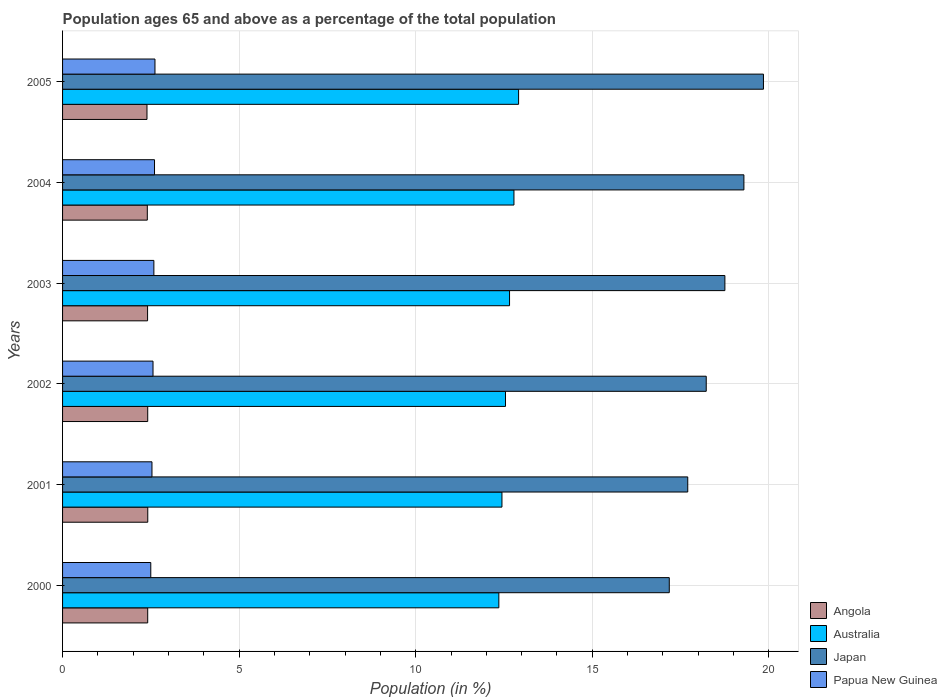Are the number of bars per tick equal to the number of legend labels?
Your answer should be very brief. Yes. How many bars are there on the 5th tick from the bottom?
Offer a terse response. 4. What is the label of the 2nd group of bars from the top?
Your answer should be very brief. 2004. What is the percentage of the population ages 65 and above in Japan in 2002?
Keep it short and to the point. 18.23. Across all years, what is the maximum percentage of the population ages 65 and above in Angola?
Offer a terse response. 2.41. Across all years, what is the minimum percentage of the population ages 65 and above in Japan?
Ensure brevity in your answer.  17.18. In which year was the percentage of the population ages 65 and above in Japan maximum?
Your answer should be very brief. 2005. In which year was the percentage of the population ages 65 and above in Angola minimum?
Provide a succinct answer. 2005. What is the total percentage of the population ages 65 and above in Angola in the graph?
Your response must be concise. 14.43. What is the difference between the percentage of the population ages 65 and above in Australia in 2002 and that in 2005?
Your answer should be compact. -0.37. What is the difference between the percentage of the population ages 65 and above in Australia in 2000 and the percentage of the population ages 65 and above in Angola in 2003?
Ensure brevity in your answer.  9.95. What is the average percentage of the population ages 65 and above in Australia per year?
Your answer should be very brief. 12.62. In the year 2000, what is the difference between the percentage of the population ages 65 and above in Papua New Guinea and percentage of the population ages 65 and above in Angola?
Offer a terse response. 0.09. What is the ratio of the percentage of the population ages 65 and above in Papua New Guinea in 2001 to that in 2003?
Your answer should be compact. 0.98. Is the percentage of the population ages 65 and above in Angola in 2000 less than that in 2003?
Provide a short and direct response. No. Is the difference between the percentage of the population ages 65 and above in Papua New Guinea in 2000 and 2003 greater than the difference between the percentage of the population ages 65 and above in Angola in 2000 and 2003?
Your response must be concise. No. What is the difference between the highest and the second highest percentage of the population ages 65 and above in Australia?
Make the answer very short. 0.13. What is the difference between the highest and the lowest percentage of the population ages 65 and above in Papua New Guinea?
Keep it short and to the point. 0.12. Is it the case that in every year, the sum of the percentage of the population ages 65 and above in Papua New Guinea and percentage of the population ages 65 and above in Japan is greater than the sum of percentage of the population ages 65 and above in Angola and percentage of the population ages 65 and above in Australia?
Your response must be concise. Yes. What does the 3rd bar from the top in 2000 represents?
Make the answer very short. Australia. What does the 1st bar from the bottom in 2000 represents?
Offer a very short reply. Angola. Are all the bars in the graph horizontal?
Provide a short and direct response. Yes. How many years are there in the graph?
Your response must be concise. 6. What is the difference between two consecutive major ticks on the X-axis?
Keep it short and to the point. 5. Are the values on the major ticks of X-axis written in scientific E-notation?
Keep it short and to the point. No. Does the graph contain any zero values?
Provide a short and direct response. No. Does the graph contain grids?
Offer a very short reply. Yes. How are the legend labels stacked?
Make the answer very short. Vertical. What is the title of the graph?
Ensure brevity in your answer.  Population ages 65 and above as a percentage of the total population. Does "Zambia" appear as one of the legend labels in the graph?
Keep it short and to the point. No. What is the label or title of the X-axis?
Your answer should be compact. Population (in %). What is the Population (in %) in Angola in 2000?
Your answer should be compact. 2.41. What is the Population (in %) of Australia in 2000?
Your answer should be very brief. 12.35. What is the Population (in %) in Japan in 2000?
Give a very brief answer. 17.18. What is the Population (in %) in Papua New Guinea in 2000?
Your answer should be very brief. 2.5. What is the Population (in %) of Angola in 2001?
Make the answer very short. 2.41. What is the Population (in %) in Australia in 2001?
Ensure brevity in your answer.  12.44. What is the Population (in %) of Japan in 2001?
Offer a very short reply. 17.7. What is the Population (in %) of Papua New Guinea in 2001?
Your answer should be very brief. 2.53. What is the Population (in %) in Angola in 2002?
Make the answer very short. 2.41. What is the Population (in %) of Australia in 2002?
Provide a short and direct response. 12.54. What is the Population (in %) of Japan in 2002?
Your answer should be very brief. 18.23. What is the Population (in %) of Papua New Guinea in 2002?
Offer a terse response. 2.56. What is the Population (in %) of Angola in 2003?
Ensure brevity in your answer.  2.41. What is the Population (in %) of Australia in 2003?
Make the answer very short. 12.66. What is the Population (in %) in Japan in 2003?
Make the answer very short. 18.75. What is the Population (in %) of Papua New Guinea in 2003?
Ensure brevity in your answer.  2.59. What is the Population (in %) in Angola in 2004?
Give a very brief answer. 2.4. What is the Population (in %) in Australia in 2004?
Your answer should be very brief. 12.78. What is the Population (in %) in Japan in 2004?
Your response must be concise. 19.29. What is the Population (in %) of Papua New Guinea in 2004?
Offer a terse response. 2.6. What is the Population (in %) of Angola in 2005?
Provide a short and direct response. 2.39. What is the Population (in %) in Australia in 2005?
Give a very brief answer. 12.91. What is the Population (in %) of Japan in 2005?
Offer a very short reply. 19.85. What is the Population (in %) in Papua New Guinea in 2005?
Provide a short and direct response. 2.62. Across all years, what is the maximum Population (in %) of Angola?
Your answer should be very brief. 2.41. Across all years, what is the maximum Population (in %) in Australia?
Make the answer very short. 12.91. Across all years, what is the maximum Population (in %) in Japan?
Ensure brevity in your answer.  19.85. Across all years, what is the maximum Population (in %) in Papua New Guinea?
Your response must be concise. 2.62. Across all years, what is the minimum Population (in %) in Angola?
Provide a short and direct response. 2.39. Across all years, what is the minimum Population (in %) in Australia?
Give a very brief answer. 12.35. Across all years, what is the minimum Population (in %) of Japan?
Offer a terse response. 17.18. Across all years, what is the minimum Population (in %) in Papua New Guinea?
Provide a short and direct response. 2.5. What is the total Population (in %) in Angola in the graph?
Your answer should be compact. 14.43. What is the total Population (in %) in Australia in the graph?
Your answer should be very brief. 75.69. What is the total Population (in %) of Japan in the graph?
Provide a short and direct response. 111.01. What is the total Population (in %) in Papua New Guinea in the graph?
Ensure brevity in your answer.  15.4. What is the difference between the Population (in %) in Angola in 2000 and that in 2001?
Keep it short and to the point. -0. What is the difference between the Population (in %) in Australia in 2000 and that in 2001?
Your response must be concise. -0.09. What is the difference between the Population (in %) in Japan in 2000 and that in 2001?
Make the answer very short. -0.52. What is the difference between the Population (in %) of Papua New Guinea in 2000 and that in 2001?
Give a very brief answer. -0.03. What is the difference between the Population (in %) of Angola in 2000 and that in 2002?
Provide a succinct answer. -0. What is the difference between the Population (in %) of Australia in 2000 and that in 2002?
Your answer should be compact. -0.19. What is the difference between the Population (in %) of Japan in 2000 and that in 2002?
Make the answer very short. -1.05. What is the difference between the Population (in %) in Papua New Guinea in 2000 and that in 2002?
Provide a succinct answer. -0.06. What is the difference between the Population (in %) in Angola in 2000 and that in 2003?
Your answer should be compact. 0. What is the difference between the Population (in %) of Australia in 2000 and that in 2003?
Your answer should be very brief. -0.3. What is the difference between the Population (in %) in Japan in 2000 and that in 2003?
Offer a very short reply. -1.57. What is the difference between the Population (in %) of Papua New Guinea in 2000 and that in 2003?
Provide a short and direct response. -0.09. What is the difference between the Population (in %) of Angola in 2000 and that in 2004?
Provide a succinct answer. 0.01. What is the difference between the Population (in %) in Australia in 2000 and that in 2004?
Your answer should be compact. -0.43. What is the difference between the Population (in %) of Japan in 2000 and that in 2004?
Your answer should be compact. -2.11. What is the difference between the Population (in %) of Papua New Guinea in 2000 and that in 2004?
Provide a short and direct response. -0.11. What is the difference between the Population (in %) of Australia in 2000 and that in 2005?
Keep it short and to the point. -0.56. What is the difference between the Population (in %) of Japan in 2000 and that in 2005?
Ensure brevity in your answer.  -2.67. What is the difference between the Population (in %) in Papua New Guinea in 2000 and that in 2005?
Provide a succinct answer. -0.12. What is the difference between the Population (in %) of Angola in 2001 and that in 2002?
Offer a terse response. 0. What is the difference between the Population (in %) of Australia in 2001 and that in 2002?
Make the answer very short. -0.1. What is the difference between the Population (in %) in Japan in 2001 and that in 2002?
Offer a very short reply. -0.52. What is the difference between the Population (in %) in Papua New Guinea in 2001 and that in 2002?
Provide a short and direct response. -0.03. What is the difference between the Population (in %) of Angola in 2001 and that in 2003?
Keep it short and to the point. 0.01. What is the difference between the Population (in %) in Australia in 2001 and that in 2003?
Make the answer very short. -0.22. What is the difference between the Population (in %) in Japan in 2001 and that in 2003?
Ensure brevity in your answer.  -1.05. What is the difference between the Population (in %) in Papua New Guinea in 2001 and that in 2003?
Your response must be concise. -0.05. What is the difference between the Population (in %) in Angola in 2001 and that in 2004?
Your response must be concise. 0.01. What is the difference between the Population (in %) in Australia in 2001 and that in 2004?
Your answer should be very brief. -0.34. What is the difference between the Population (in %) in Japan in 2001 and that in 2004?
Offer a terse response. -1.59. What is the difference between the Population (in %) in Papua New Guinea in 2001 and that in 2004?
Offer a very short reply. -0.07. What is the difference between the Population (in %) of Angola in 2001 and that in 2005?
Make the answer very short. 0.02. What is the difference between the Population (in %) of Australia in 2001 and that in 2005?
Provide a succinct answer. -0.47. What is the difference between the Population (in %) in Japan in 2001 and that in 2005?
Give a very brief answer. -2.14. What is the difference between the Population (in %) of Papua New Guinea in 2001 and that in 2005?
Make the answer very short. -0.08. What is the difference between the Population (in %) of Angola in 2002 and that in 2003?
Provide a succinct answer. 0. What is the difference between the Population (in %) in Australia in 2002 and that in 2003?
Offer a very short reply. -0.11. What is the difference between the Population (in %) in Japan in 2002 and that in 2003?
Your response must be concise. -0.53. What is the difference between the Population (in %) of Papua New Guinea in 2002 and that in 2003?
Ensure brevity in your answer.  -0.02. What is the difference between the Population (in %) of Angola in 2002 and that in 2004?
Offer a very short reply. 0.01. What is the difference between the Population (in %) of Australia in 2002 and that in 2004?
Make the answer very short. -0.24. What is the difference between the Population (in %) in Japan in 2002 and that in 2004?
Your answer should be compact. -1.07. What is the difference between the Population (in %) in Papua New Guinea in 2002 and that in 2004?
Your response must be concise. -0.04. What is the difference between the Population (in %) of Angola in 2002 and that in 2005?
Offer a very short reply. 0.02. What is the difference between the Population (in %) of Australia in 2002 and that in 2005?
Provide a short and direct response. -0.37. What is the difference between the Population (in %) in Japan in 2002 and that in 2005?
Provide a succinct answer. -1.62. What is the difference between the Population (in %) of Papua New Guinea in 2002 and that in 2005?
Your answer should be compact. -0.06. What is the difference between the Population (in %) in Angola in 2003 and that in 2004?
Provide a succinct answer. 0.01. What is the difference between the Population (in %) of Australia in 2003 and that in 2004?
Your response must be concise. -0.12. What is the difference between the Population (in %) in Japan in 2003 and that in 2004?
Offer a terse response. -0.54. What is the difference between the Population (in %) of Papua New Guinea in 2003 and that in 2004?
Give a very brief answer. -0.02. What is the difference between the Population (in %) in Angola in 2003 and that in 2005?
Make the answer very short. 0.02. What is the difference between the Population (in %) in Australia in 2003 and that in 2005?
Your response must be concise. -0.26. What is the difference between the Population (in %) of Japan in 2003 and that in 2005?
Provide a succinct answer. -1.09. What is the difference between the Population (in %) of Papua New Guinea in 2003 and that in 2005?
Ensure brevity in your answer.  -0.03. What is the difference between the Population (in %) in Angola in 2004 and that in 2005?
Your answer should be compact. 0.01. What is the difference between the Population (in %) in Australia in 2004 and that in 2005?
Offer a very short reply. -0.13. What is the difference between the Population (in %) of Japan in 2004 and that in 2005?
Your answer should be very brief. -0.55. What is the difference between the Population (in %) in Papua New Guinea in 2004 and that in 2005?
Your response must be concise. -0.01. What is the difference between the Population (in %) of Angola in 2000 and the Population (in %) of Australia in 2001?
Your answer should be very brief. -10.03. What is the difference between the Population (in %) of Angola in 2000 and the Population (in %) of Japan in 2001?
Provide a succinct answer. -15.29. What is the difference between the Population (in %) in Angola in 2000 and the Population (in %) in Papua New Guinea in 2001?
Offer a terse response. -0.12. What is the difference between the Population (in %) of Australia in 2000 and the Population (in %) of Japan in 2001?
Give a very brief answer. -5.35. What is the difference between the Population (in %) of Australia in 2000 and the Population (in %) of Papua New Guinea in 2001?
Provide a succinct answer. 9.82. What is the difference between the Population (in %) in Japan in 2000 and the Population (in %) in Papua New Guinea in 2001?
Offer a terse response. 14.65. What is the difference between the Population (in %) of Angola in 2000 and the Population (in %) of Australia in 2002?
Keep it short and to the point. -10.13. What is the difference between the Population (in %) of Angola in 2000 and the Population (in %) of Japan in 2002?
Your answer should be compact. -15.82. What is the difference between the Population (in %) in Angola in 2000 and the Population (in %) in Papua New Guinea in 2002?
Ensure brevity in your answer.  -0.15. What is the difference between the Population (in %) of Australia in 2000 and the Population (in %) of Japan in 2002?
Offer a very short reply. -5.87. What is the difference between the Population (in %) in Australia in 2000 and the Population (in %) in Papua New Guinea in 2002?
Keep it short and to the point. 9.79. What is the difference between the Population (in %) in Japan in 2000 and the Population (in %) in Papua New Guinea in 2002?
Your answer should be very brief. 14.62. What is the difference between the Population (in %) in Angola in 2000 and the Population (in %) in Australia in 2003?
Ensure brevity in your answer.  -10.25. What is the difference between the Population (in %) of Angola in 2000 and the Population (in %) of Japan in 2003?
Offer a terse response. -16.34. What is the difference between the Population (in %) of Angola in 2000 and the Population (in %) of Papua New Guinea in 2003?
Provide a succinct answer. -0.17. What is the difference between the Population (in %) in Australia in 2000 and the Population (in %) in Japan in 2003?
Give a very brief answer. -6.4. What is the difference between the Population (in %) of Australia in 2000 and the Population (in %) of Papua New Guinea in 2003?
Your answer should be compact. 9.77. What is the difference between the Population (in %) in Japan in 2000 and the Population (in %) in Papua New Guinea in 2003?
Give a very brief answer. 14.6. What is the difference between the Population (in %) in Angola in 2000 and the Population (in %) in Australia in 2004?
Ensure brevity in your answer.  -10.37. What is the difference between the Population (in %) of Angola in 2000 and the Population (in %) of Japan in 2004?
Keep it short and to the point. -16.88. What is the difference between the Population (in %) of Angola in 2000 and the Population (in %) of Papua New Guinea in 2004?
Provide a short and direct response. -0.19. What is the difference between the Population (in %) in Australia in 2000 and the Population (in %) in Japan in 2004?
Make the answer very short. -6.94. What is the difference between the Population (in %) in Australia in 2000 and the Population (in %) in Papua New Guinea in 2004?
Your answer should be compact. 9.75. What is the difference between the Population (in %) in Japan in 2000 and the Population (in %) in Papua New Guinea in 2004?
Your answer should be compact. 14.58. What is the difference between the Population (in %) in Angola in 2000 and the Population (in %) in Australia in 2005?
Give a very brief answer. -10.5. What is the difference between the Population (in %) in Angola in 2000 and the Population (in %) in Japan in 2005?
Keep it short and to the point. -17.44. What is the difference between the Population (in %) in Angola in 2000 and the Population (in %) in Papua New Guinea in 2005?
Your answer should be compact. -0.21. What is the difference between the Population (in %) of Australia in 2000 and the Population (in %) of Japan in 2005?
Provide a short and direct response. -7.49. What is the difference between the Population (in %) of Australia in 2000 and the Population (in %) of Papua New Guinea in 2005?
Keep it short and to the point. 9.74. What is the difference between the Population (in %) in Japan in 2000 and the Population (in %) in Papua New Guinea in 2005?
Offer a terse response. 14.56. What is the difference between the Population (in %) of Angola in 2001 and the Population (in %) of Australia in 2002?
Your answer should be very brief. -10.13. What is the difference between the Population (in %) of Angola in 2001 and the Population (in %) of Japan in 2002?
Make the answer very short. -15.81. What is the difference between the Population (in %) in Angola in 2001 and the Population (in %) in Papua New Guinea in 2002?
Keep it short and to the point. -0.15. What is the difference between the Population (in %) of Australia in 2001 and the Population (in %) of Japan in 2002?
Offer a very short reply. -5.78. What is the difference between the Population (in %) in Australia in 2001 and the Population (in %) in Papua New Guinea in 2002?
Make the answer very short. 9.88. What is the difference between the Population (in %) of Japan in 2001 and the Population (in %) of Papua New Guinea in 2002?
Make the answer very short. 15.14. What is the difference between the Population (in %) of Angola in 2001 and the Population (in %) of Australia in 2003?
Give a very brief answer. -10.24. What is the difference between the Population (in %) of Angola in 2001 and the Population (in %) of Japan in 2003?
Ensure brevity in your answer.  -16.34. What is the difference between the Population (in %) of Angola in 2001 and the Population (in %) of Papua New Guinea in 2003?
Offer a very short reply. -0.17. What is the difference between the Population (in %) in Australia in 2001 and the Population (in %) in Japan in 2003?
Your response must be concise. -6.31. What is the difference between the Population (in %) in Australia in 2001 and the Population (in %) in Papua New Guinea in 2003?
Offer a very short reply. 9.86. What is the difference between the Population (in %) in Japan in 2001 and the Population (in %) in Papua New Guinea in 2003?
Ensure brevity in your answer.  15.12. What is the difference between the Population (in %) of Angola in 2001 and the Population (in %) of Australia in 2004?
Your response must be concise. -10.37. What is the difference between the Population (in %) of Angola in 2001 and the Population (in %) of Japan in 2004?
Keep it short and to the point. -16.88. What is the difference between the Population (in %) of Angola in 2001 and the Population (in %) of Papua New Guinea in 2004?
Make the answer very short. -0.19. What is the difference between the Population (in %) of Australia in 2001 and the Population (in %) of Japan in 2004?
Ensure brevity in your answer.  -6.85. What is the difference between the Population (in %) of Australia in 2001 and the Population (in %) of Papua New Guinea in 2004?
Offer a very short reply. 9.84. What is the difference between the Population (in %) of Japan in 2001 and the Population (in %) of Papua New Guinea in 2004?
Your response must be concise. 15.1. What is the difference between the Population (in %) in Angola in 2001 and the Population (in %) in Australia in 2005?
Your response must be concise. -10.5. What is the difference between the Population (in %) in Angola in 2001 and the Population (in %) in Japan in 2005?
Keep it short and to the point. -17.43. What is the difference between the Population (in %) in Angola in 2001 and the Population (in %) in Papua New Guinea in 2005?
Your answer should be compact. -0.2. What is the difference between the Population (in %) of Australia in 2001 and the Population (in %) of Japan in 2005?
Offer a very short reply. -7.4. What is the difference between the Population (in %) in Australia in 2001 and the Population (in %) in Papua New Guinea in 2005?
Offer a terse response. 9.83. What is the difference between the Population (in %) of Japan in 2001 and the Population (in %) of Papua New Guinea in 2005?
Ensure brevity in your answer.  15.09. What is the difference between the Population (in %) in Angola in 2002 and the Population (in %) in Australia in 2003?
Provide a short and direct response. -10.25. What is the difference between the Population (in %) of Angola in 2002 and the Population (in %) of Japan in 2003?
Your answer should be very brief. -16.34. What is the difference between the Population (in %) in Angola in 2002 and the Population (in %) in Papua New Guinea in 2003?
Provide a succinct answer. -0.17. What is the difference between the Population (in %) in Australia in 2002 and the Population (in %) in Japan in 2003?
Offer a very short reply. -6.21. What is the difference between the Population (in %) in Australia in 2002 and the Population (in %) in Papua New Guinea in 2003?
Your response must be concise. 9.96. What is the difference between the Population (in %) in Japan in 2002 and the Population (in %) in Papua New Guinea in 2003?
Offer a very short reply. 15.64. What is the difference between the Population (in %) of Angola in 2002 and the Population (in %) of Australia in 2004?
Offer a very short reply. -10.37. What is the difference between the Population (in %) of Angola in 2002 and the Population (in %) of Japan in 2004?
Offer a very short reply. -16.88. What is the difference between the Population (in %) in Angola in 2002 and the Population (in %) in Papua New Guinea in 2004?
Provide a succinct answer. -0.19. What is the difference between the Population (in %) in Australia in 2002 and the Population (in %) in Japan in 2004?
Ensure brevity in your answer.  -6.75. What is the difference between the Population (in %) in Australia in 2002 and the Population (in %) in Papua New Guinea in 2004?
Offer a very short reply. 9.94. What is the difference between the Population (in %) in Japan in 2002 and the Population (in %) in Papua New Guinea in 2004?
Give a very brief answer. 15.62. What is the difference between the Population (in %) in Angola in 2002 and the Population (in %) in Australia in 2005?
Offer a terse response. -10.5. What is the difference between the Population (in %) of Angola in 2002 and the Population (in %) of Japan in 2005?
Make the answer very short. -17.44. What is the difference between the Population (in %) of Angola in 2002 and the Population (in %) of Papua New Guinea in 2005?
Your answer should be very brief. -0.2. What is the difference between the Population (in %) of Australia in 2002 and the Population (in %) of Japan in 2005?
Provide a short and direct response. -7.3. What is the difference between the Population (in %) in Australia in 2002 and the Population (in %) in Papua New Guinea in 2005?
Provide a short and direct response. 9.93. What is the difference between the Population (in %) of Japan in 2002 and the Population (in %) of Papua New Guinea in 2005?
Provide a succinct answer. 15.61. What is the difference between the Population (in %) in Angola in 2003 and the Population (in %) in Australia in 2004?
Keep it short and to the point. -10.37. What is the difference between the Population (in %) of Angola in 2003 and the Population (in %) of Japan in 2004?
Provide a short and direct response. -16.89. What is the difference between the Population (in %) in Angola in 2003 and the Population (in %) in Papua New Guinea in 2004?
Provide a succinct answer. -0.2. What is the difference between the Population (in %) in Australia in 2003 and the Population (in %) in Japan in 2004?
Offer a very short reply. -6.64. What is the difference between the Population (in %) in Australia in 2003 and the Population (in %) in Papua New Guinea in 2004?
Your answer should be compact. 10.05. What is the difference between the Population (in %) in Japan in 2003 and the Population (in %) in Papua New Guinea in 2004?
Offer a very short reply. 16.15. What is the difference between the Population (in %) of Angola in 2003 and the Population (in %) of Australia in 2005?
Provide a short and direct response. -10.51. What is the difference between the Population (in %) in Angola in 2003 and the Population (in %) in Japan in 2005?
Offer a very short reply. -17.44. What is the difference between the Population (in %) in Angola in 2003 and the Population (in %) in Papua New Guinea in 2005?
Provide a short and direct response. -0.21. What is the difference between the Population (in %) of Australia in 2003 and the Population (in %) of Japan in 2005?
Provide a succinct answer. -7.19. What is the difference between the Population (in %) of Australia in 2003 and the Population (in %) of Papua New Guinea in 2005?
Ensure brevity in your answer.  10.04. What is the difference between the Population (in %) in Japan in 2003 and the Population (in %) in Papua New Guinea in 2005?
Your answer should be very brief. 16.14. What is the difference between the Population (in %) of Angola in 2004 and the Population (in %) of Australia in 2005?
Provide a succinct answer. -10.51. What is the difference between the Population (in %) in Angola in 2004 and the Population (in %) in Japan in 2005?
Give a very brief answer. -17.45. What is the difference between the Population (in %) in Angola in 2004 and the Population (in %) in Papua New Guinea in 2005?
Your response must be concise. -0.22. What is the difference between the Population (in %) in Australia in 2004 and the Population (in %) in Japan in 2005?
Make the answer very short. -7.06. What is the difference between the Population (in %) of Australia in 2004 and the Population (in %) of Papua New Guinea in 2005?
Give a very brief answer. 10.17. What is the difference between the Population (in %) in Japan in 2004 and the Population (in %) in Papua New Guinea in 2005?
Offer a very short reply. 16.68. What is the average Population (in %) of Angola per year?
Offer a very short reply. 2.41. What is the average Population (in %) in Australia per year?
Offer a very short reply. 12.62. What is the average Population (in %) of Japan per year?
Keep it short and to the point. 18.5. What is the average Population (in %) of Papua New Guinea per year?
Make the answer very short. 2.57. In the year 2000, what is the difference between the Population (in %) in Angola and Population (in %) in Australia?
Keep it short and to the point. -9.94. In the year 2000, what is the difference between the Population (in %) in Angola and Population (in %) in Japan?
Provide a succinct answer. -14.77. In the year 2000, what is the difference between the Population (in %) in Angola and Population (in %) in Papua New Guinea?
Provide a short and direct response. -0.09. In the year 2000, what is the difference between the Population (in %) of Australia and Population (in %) of Japan?
Give a very brief answer. -4.83. In the year 2000, what is the difference between the Population (in %) in Australia and Population (in %) in Papua New Guinea?
Make the answer very short. 9.86. In the year 2000, what is the difference between the Population (in %) of Japan and Population (in %) of Papua New Guinea?
Your response must be concise. 14.68. In the year 2001, what is the difference between the Population (in %) in Angola and Population (in %) in Australia?
Your answer should be compact. -10.03. In the year 2001, what is the difference between the Population (in %) of Angola and Population (in %) of Japan?
Keep it short and to the point. -15.29. In the year 2001, what is the difference between the Population (in %) in Angola and Population (in %) in Papua New Guinea?
Your response must be concise. -0.12. In the year 2001, what is the difference between the Population (in %) of Australia and Population (in %) of Japan?
Your answer should be very brief. -5.26. In the year 2001, what is the difference between the Population (in %) in Australia and Population (in %) in Papua New Guinea?
Keep it short and to the point. 9.91. In the year 2001, what is the difference between the Population (in %) of Japan and Population (in %) of Papua New Guinea?
Provide a succinct answer. 15.17. In the year 2002, what is the difference between the Population (in %) of Angola and Population (in %) of Australia?
Ensure brevity in your answer.  -10.13. In the year 2002, what is the difference between the Population (in %) of Angola and Population (in %) of Japan?
Provide a short and direct response. -15.81. In the year 2002, what is the difference between the Population (in %) of Angola and Population (in %) of Papua New Guinea?
Keep it short and to the point. -0.15. In the year 2002, what is the difference between the Population (in %) of Australia and Population (in %) of Japan?
Keep it short and to the point. -5.68. In the year 2002, what is the difference between the Population (in %) of Australia and Population (in %) of Papua New Guinea?
Provide a short and direct response. 9.98. In the year 2002, what is the difference between the Population (in %) in Japan and Population (in %) in Papua New Guinea?
Provide a short and direct response. 15.67. In the year 2003, what is the difference between the Population (in %) of Angola and Population (in %) of Australia?
Your answer should be compact. -10.25. In the year 2003, what is the difference between the Population (in %) in Angola and Population (in %) in Japan?
Make the answer very short. -16.35. In the year 2003, what is the difference between the Population (in %) in Angola and Population (in %) in Papua New Guinea?
Offer a very short reply. -0.18. In the year 2003, what is the difference between the Population (in %) of Australia and Population (in %) of Japan?
Make the answer very short. -6.1. In the year 2003, what is the difference between the Population (in %) in Australia and Population (in %) in Papua New Guinea?
Provide a short and direct response. 10.07. In the year 2003, what is the difference between the Population (in %) in Japan and Population (in %) in Papua New Guinea?
Keep it short and to the point. 16.17. In the year 2004, what is the difference between the Population (in %) in Angola and Population (in %) in Australia?
Ensure brevity in your answer.  -10.38. In the year 2004, what is the difference between the Population (in %) of Angola and Population (in %) of Japan?
Offer a terse response. -16.89. In the year 2004, what is the difference between the Population (in %) of Angola and Population (in %) of Papua New Guinea?
Provide a short and direct response. -0.2. In the year 2004, what is the difference between the Population (in %) of Australia and Population (in %) of Japan?
Make the answer very short. -6.51. In the year 2004, what is the difference between the Population (in %) in Australia and Population (in %) in Papua New Guinea?
Your response must be concise. 10.18. In the year 2004, what is the difference between the Population (in %) in Japan and Population (in %) in Papua New Guinea?
Give a very brief answer. 16.69. In the year 2005, what is the difference between the Population (in %) of Angola and Population (in %) of Australia?
Offer a very short reply. -10.52. In the year 2005, what is the difference between the Population (in %) in Angola and Population (in %) in Japan?
Your answer should be compact. -17.46. In the year 2005, what is the difference between the Population (in %) of Angola and Population (in %) of Papua New Guinea?
Provide a short and direct response. -0.23. In the year 2005, what is the difference between the Population (in %) in Australia and Population (in %) in Japan?
Your answer should be very brief. -6.93. In the year 2005, what is the difference between the Population (in %) of Australia and Population (in %) of Papua New Guinea?
Make the answer very short. 10.3. In the year 2005, what is the difference between the Population (in %) in Japan and Population (in %) in Papua New Guinea?
Give a very brief answer. 17.23. What is the ratio of the Population (in %) of Australia in 2000 to that in 2001?
Offer a terse response. 0.99. What is the ratio of the Population (in %) of Japan in 2000 to that in 2001?
Your answer should be very brief. 0.97. What is the ratio of the Population (in %) of Papua New Guinea in 2000 to that in 2001?
Ensure brevity in your answer.  0.99. What is the ratio of the Population (in %) in Japan in 2000 to that in 2002?
Ensure brevity in your answer.  0.94. What is the ratio of the Population (in %) in Papua New Guinea in 2000 to that in 2002?
Ensure brevity in your answer.  0.98. What is the ratio of the Population (in %) of Japan in 2000 to that in 2003?
Keep it short and to the point. 0.92. What is the ratio of the Population (in %) of Papua New Guinea in 2000 to that in 2003?
Ensure brevity in your answer.  0.97. What is the ratio of the Population (in %) of Angola in 2000 to that in 2004?
Offer a very short reply. 1. What is the ratio of the Population (in %) in Australia in 2000 to that in 2004?
Your answer should be compact. 0.97. What is the ratio of the Population (in %) of Japan in 2000 to that in 2004?
Your answer should be very brief. 0.89. What is the ratio of the Population (in %) in Papua New Guinea in 2000 to that in 2004?
Offer a terse response. 0.96. What is the ratio of the Population (in %) in Angola in 2000 to that in 2005?
Keep it short and to the point. 1.01. What is the ratio of the Population (in %) of Australia in 2000 to that in 2005?
Your answer should be very brief. 0.96. What is the ratio of the Population (in %) in Japan in 2000 to that in 2005?
Give a very brief answer. 0.87. What is the ratio of the Population (in %) in Papua New Guinea in 2000 to that in 2005?
Provide a short and direct response. 0.95. What is the ratio of the Population (in %) of Angola in 2001 to that in 2002?
Provide a short and direct response. 1. What is the ratio of the Population (in %) of Australia in 2001 to that in 2002?
Keep it short and to the point. 0.99. What is the ratio of the Population (in %) of Japan in 2001 to that in 2002?
Your answer should be very brief. 0.97. What is the ratio of the Population (in %) of Papua New Guinea in 2001 to that in 2002?
Offer a terse response. 0.99. What is the ratio of the Population (in %) of Japan in 2001 to that in 2003?
Your response must be concise. 0.94. What is the ratio of the Population (in %) in Papua New Guinea in 2001 to that in 2003?
Make the answer very short. 0.98. What is the ratio of the Population (in %) in Australia in 2001 to that in 2004?
Offer a terse response. 0.97. What is the ratio of the Population (in %) in Japan in 2001 to that in 2004?
Ensure brevity in your answer.  0.92. What is the ratio of the Population (in %) in Papua New Guinea in 2001 to that in 2004?
Ensure brevity in your answer.  0.97. What is the ratio of the Population (in %) in Angola in 2001 to that in 2005?
Your answer should be very brief. 1.01. What is the ratio of the Population (in %) in Australia in 2001 to that in 2005?
Offer a very short reply. 0.96. What is the ratio of the Population (in %) in Japan in 2001 to that in 2005?
Provide a succinct answer. 0.89. What is the ratio of the Population (in %) in Papua New Guinea in 2001 to that in 2005?
Offer a terse response. 0.97. What is the ratio of the Population (in %) of Angola in 2002 to that in 2003?
Your response must be concise. 1. What is the ratio of the Population (in %) in Australia in 2002 to that in 2003?
Offer a very short reply. 0.99. What is the ratio of the Population (in %) in Japan in 2002 to that in 2003?
Provide a short and direct response. 0.97. What is the ratio of the Population (in %) of Papua New Guinea in 2002 to that in 2003?
Provide a short and direct response. 0.99. What is the ratio of the Population (in %) in Australia in 2002 to that in 2004?
Your answer should be compact. 0.98. What is the ratio of the Population (in %) of Japan in 2002 to that in 2004?
Offer a terse response. 0.94. What is the ratio of the Population (in %) in Papua New Guinea in 2002 to that in 2004?
Provide a short and direct response. 0.98. What is the ratio of the Population (in %) in Angola in 2002 to that in 2005?
Offer a very short reply. 1.01. What is the ratio of the Population (in %) of Australia in 2002 to that in 2005?
Give a very brief answer. 0.97. What is the ratio of the Population (in %) in Japan in 2002 to that in 2005?
Give a very brief answer. 0.92. What is the ratio of the Population (in %) of Papua New Guinea in 2002 to that in 2005?
Provide a succinct answer. 0.98. What is the ratio of the Population (in %) of Angola in 2003 to that in 2004?
Keep it short and to the point. 1. What is the ratio of the Population (in %) of Australia in 2003 to that in 2004?
Make the answer very short. 0.99. What is the ratio of the Population (in %) of Japan in 2003 to that in 2004?
Offer a very short reply. 0.97. What is the ratio of the Population (in %) in Papua New Guinea in 2003 to that in 2004?
Make the answer very short. 0.99. What is the ratio of the Population (in %) in Australia in 2003 to that in 2005?
Offer a very short reply. 0.98. What is the ratio of the Population (in %) of Japan in 2003 to that in 2005?
Your answer should be compact. 0.94. What is the ratio of the Population (in %) in Australia in 2004 to that in 2005?
Keep it short and to the point. 0.99. What is the ratio of the Population (in %) of Japan in 2004 to that in 2005?
Offer a terse response. 0.97. What is the ratio of the Population (in %) of Papua New Guinea in 2004 to that in 2005?
Ensure brevity in your answer.  1. What is the difference between the highest and the second highest Population (in %) of Angola?
Keep it short and to the point. 0. What is the difference between the highest and the second highest Population (in %) of Australia?
Keep it short and to the point. 0.13. What is the difference between the highest and the second highest Population (in %) of Japan?
Your answer should be compact. 0.55. What is the difference between the highest and the second highest Population (in %) in Papua New Guinea?
Offer a very short reply. 0.01. What is the difference between the highest and the lowest Population (in %) in Angola?
Ensure brevity in your answer.  0.02. What is the difference between the highest and the lowest Population (in %) in Australia?
Provide a short and direct response. 0.56. What is the difference between the highest and the lowest Population (in %) of Japan?
Provide a succinct answer. 2.67. What is the difference between the highest and the lowest Population (in %) of Papua New Guinea?
Your answer should be very brief. 0.12. 